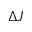<formula> <loc_0><loc_0><loc_500><loc_500>\Delta { J }</formula> 